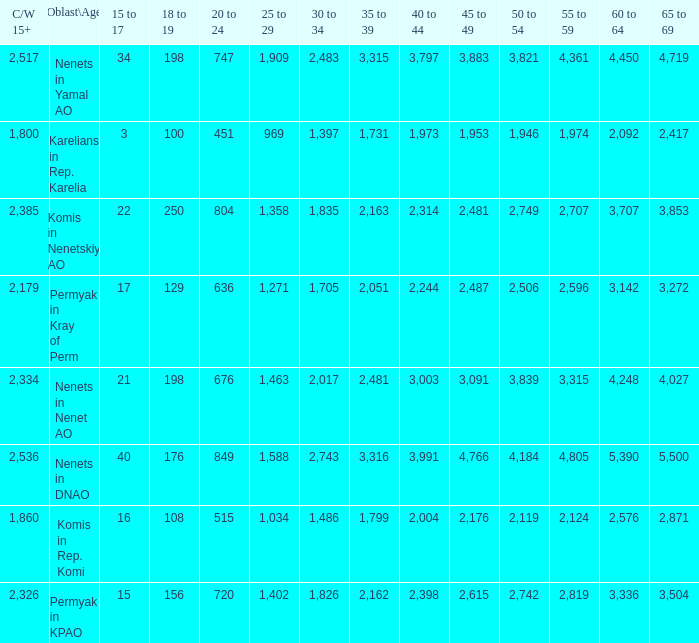What is the total 60 to 64 when the Oblast\Age is Nenets in Yamal AO, and the 45 to 49 is bigger than 3,883? None. 